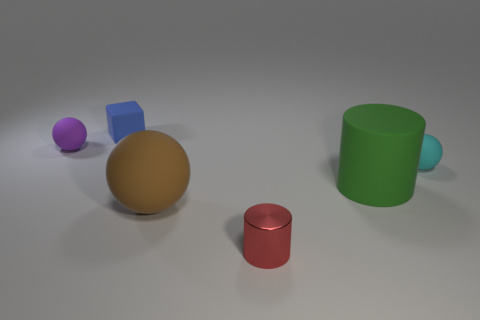Add 1 blocks. How many objects exist? 7 Subtract all cylinders. How many objects are left? 4 Add 3 cylinders. How many cylinders are left? 5 Add 3 small shiny things. How many small shiny things exist? 4 Subtract 0 gray cylinders. How many objects are left? 6 Subtract all matte blocks. Subtract all purple matte objects. How many objects are left? 4 